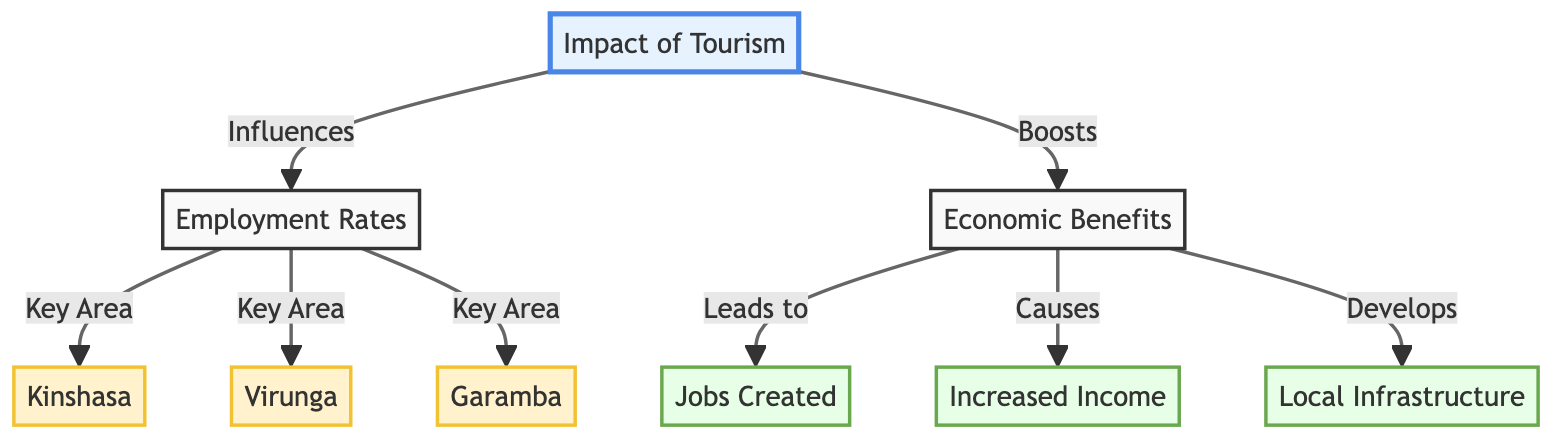What are the three key areas mentioned in the diagram? The diagram lists three regions under "Employment Rates," which are Kinshasa, Virunga, and Garamba.
Answer: Kinshasa, Virunga, Garamba What does tourism impact lead to in the economic benefits section? The economic benefits section lists three outcomes stemming from tourism's impact, which are jobs created, increased income, and local infrastructure.
Answer: Jobs created, increased income, local infrastructure How many nodes are connected to employment rates? The "Employment Rates" node connects to three regions: Kinshasa, Virunga, and Garamba, indicating a total of three connections.
Answer: 3 What is the relationship between economic benefits and local infrastructure? The diagram specifies that economic benefits "Develops" local infrastructure, demonstrating a direct influence of economic benefits on local infrastructure development.
Answer: Develops Which node indicates a boost to economic benefits? The arrow from "Impact of Tourism" to "Economic Benefits" shows that tourism influences or boosts economic benefits.
Answer: Boosts What is the main focus of the diagram? The central theme of the diagram is to illustrate "Impact of Tourism" on local communities, specifically concerning employment rates and economic benefits in key regions.
Answer: Impact of Tourism What is the significance of Virunga in the diagram? Virunga is one of the key areas mentioned under "Employment Rates," indicating its importance in terms of employment outcomes tied to tourism.
Answer: Key Area How does employment rates connect to economic benefits? The connection between employment rates and economic benefits is implicit in the influence tourism has on both aspects, showcasing their relationship in the context of tourism's impact.
Answer: Implicit connection 